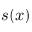<formula> <loc_0><loc_0><loc_500><loc_500>s ( x )</formula> 